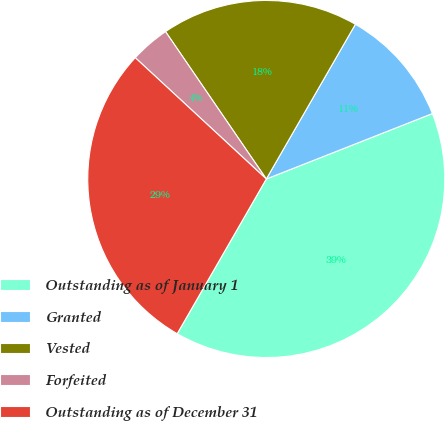Convert chart. <chart><loc_0><loc_0><loc_500><loc_500><pie_chart><fcel>Outstanding as of January 1<fcel>Granted<fcel>Vested<fcel>Forfeited<fcel>Outstanding as of December 31<nl><fcel>39.29%<fcel>10.71%<fcel>17.86%<fcel>3.57%<fcel>28.57%<nl></chart> 